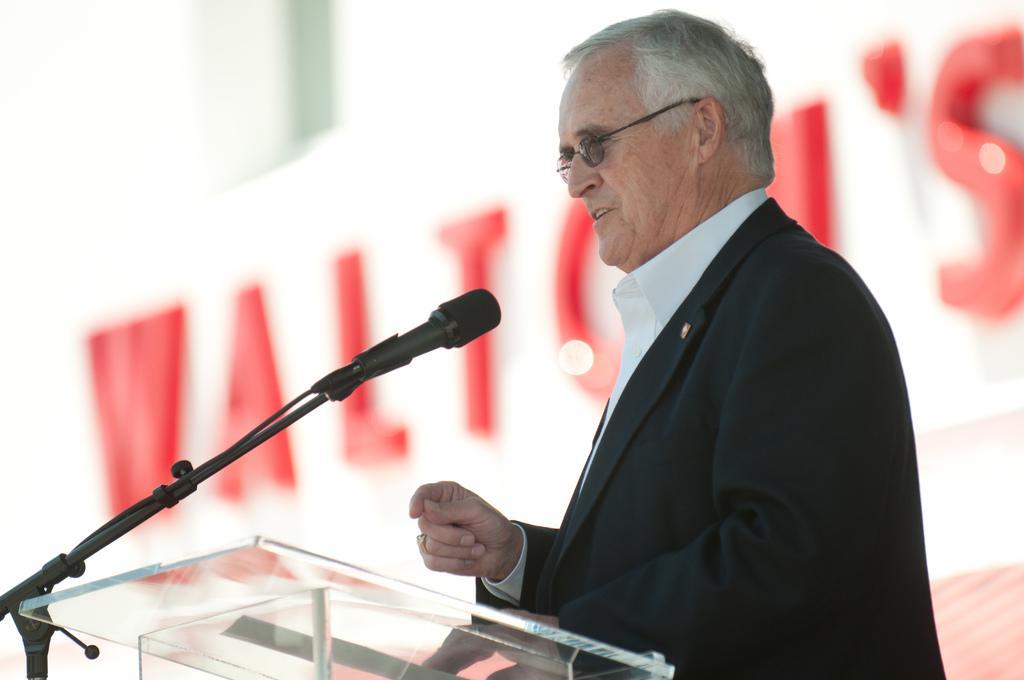How would you summarize this image in a sentence or two? In this picture we can see a man wore a blazer, spectacles, standing at the podium and in front of him we can see a mic and in the background we can see a name on the wall and it is blur. 